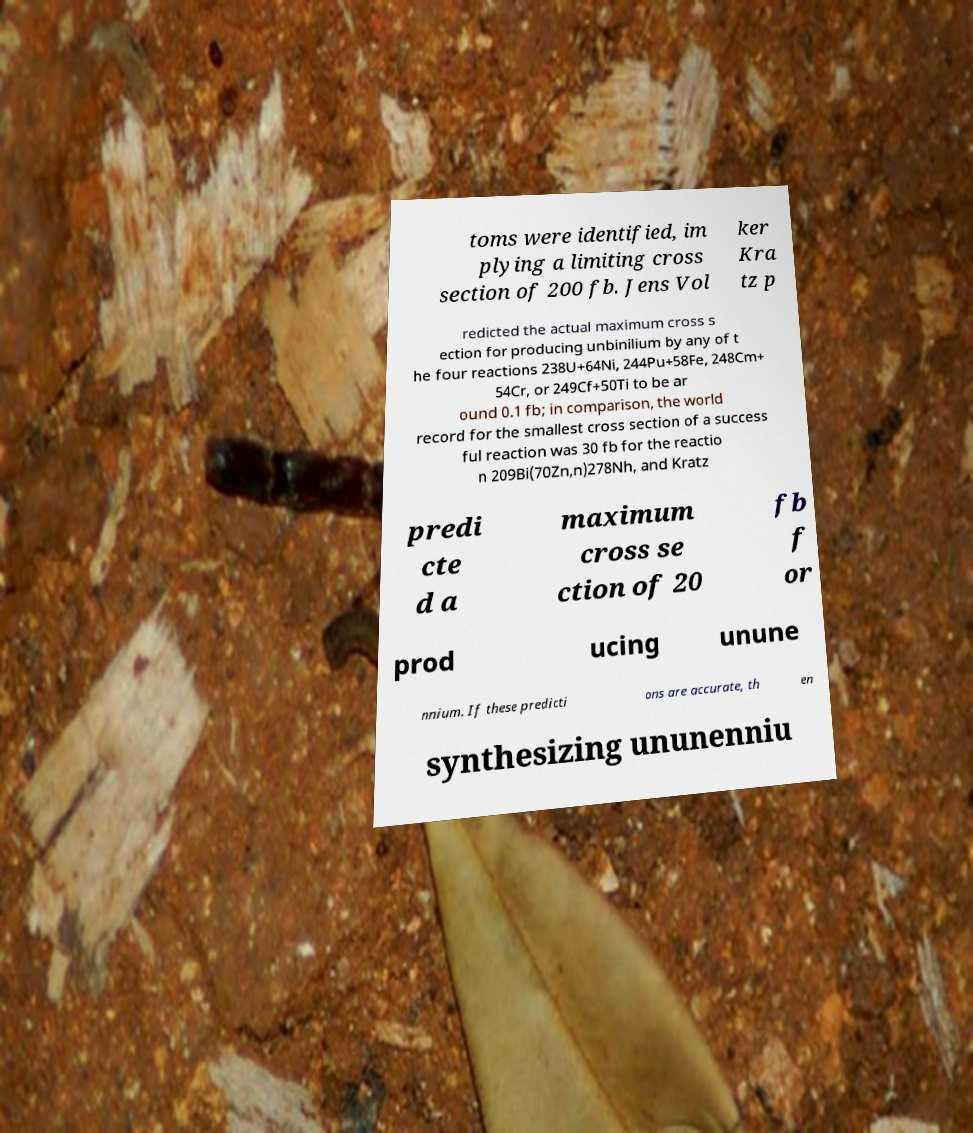I need the written content from this picture converted into text. Can you do that? toms were identified, im plying a limiting cross section of 200 fb. Jens Vol ker Kra tz p redicted the actual maximum cross s ection for producing unbinilium by any of t he four reactions 238U+64Ni, 244Pu+58Fe, 248Cm+ 54Cr, or 249Cf+50Ti to be ar ound 0.1 fb; in comparison, the world record for the smallest cross section of a success ful reaction was 30 fb for the reactio n 209Bi(70Zn,n)278Nh, and Kratz predi cte d a maximum cross se ction of 20 fb f or prod ucing unune nnium. If these predicti ons are accurate, th en synthesizing ununenniu 